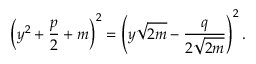<formula> <loc_0><loc_0><loc_500><loc_500>\left ( y ^ { 2 } + { \frac { p } { 2 } } + m \right ) ^ { 2 } = \left ( y { \sqrt { 2 m } } - { \frac { q } { 2 { \sqrt { 2 m } } } } \right ) ^ { 2 } .</formula> 